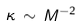Convert formula to latex. <formula><loc_0><loc_0><loc_500><loc_500>\kappa \, \sim \, M ^ { - 2 }</formula> 